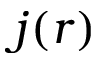Convert formula to latex. <formula><loc_0><loc_0><loc_500><loc_500>j ( r )</formula> 